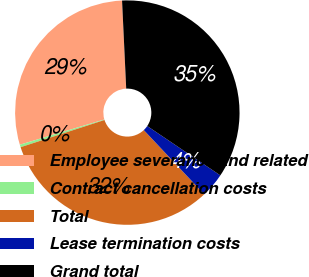Convert chart to OTSL. <chart><loc_0><loc_0><loc_500><loc_500><pie_chart><fcel>Employee severance and related<fcel>Contract cancellation costs<fcel>Total<fcel>Lease termination costs<fcel>Grand total<nl><fcel>28.87%<fcel>0.37%<fcel>32.03%<fcel>3.53%<fcel>35.2%<nl></chart> 